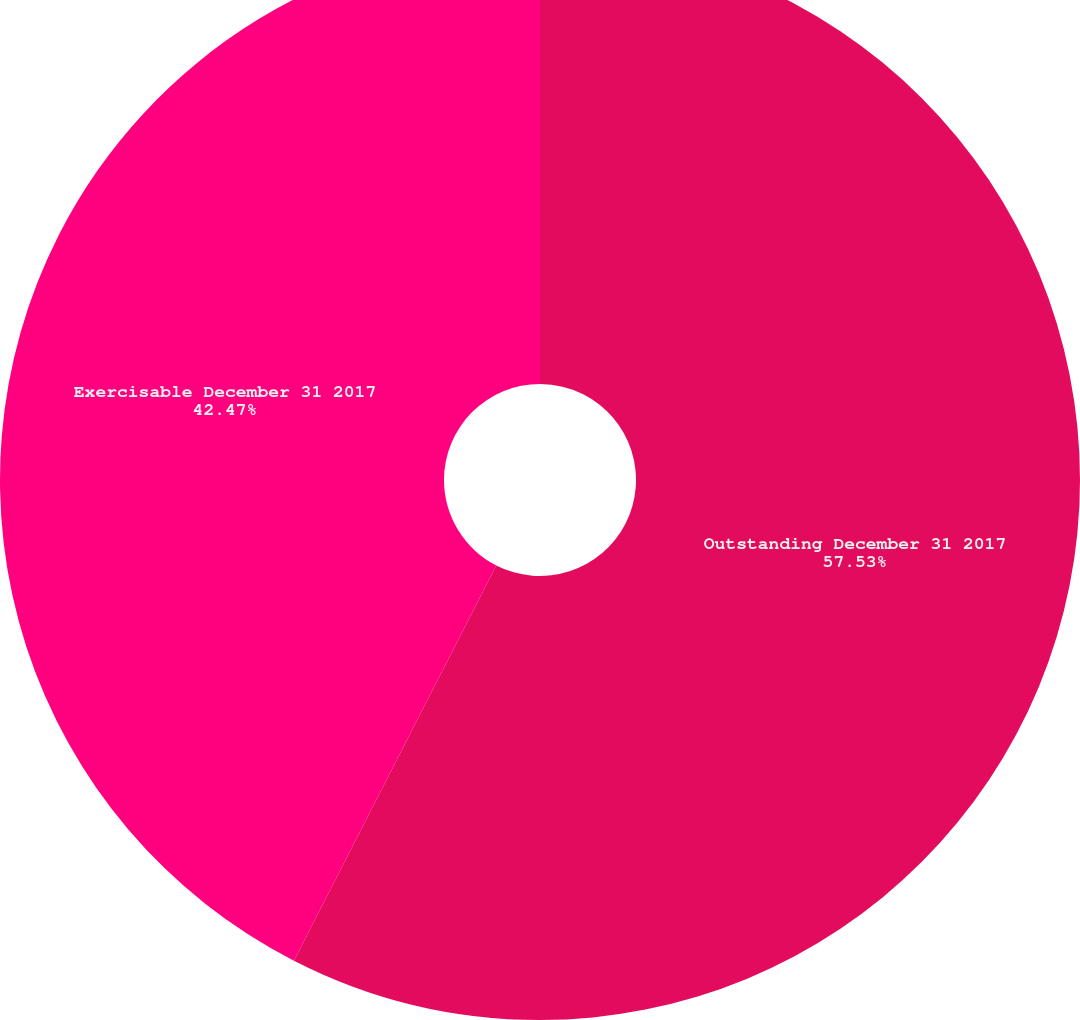<chart> <loc_0><loc_0><loc_500><loc_500><pie_chart><fcel>Outstanding December 31 2017<fcel>Exercisable December 31 2017<nl><fcel>57.53%<fcel>42.47%<nl></chart> 